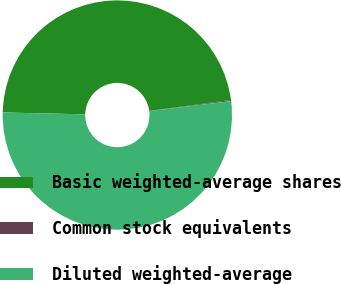Convert chart. <chart><loc_0><loc_0><loc_500><loc_500><pie_chart><fcel>Basic weighted-average shares<fcel>Common stock equivalents<fcel>Diluted weighted-average<nl><fcel>47.55%<fcel>0.14%<fcel>52.31%<nl></chart> 